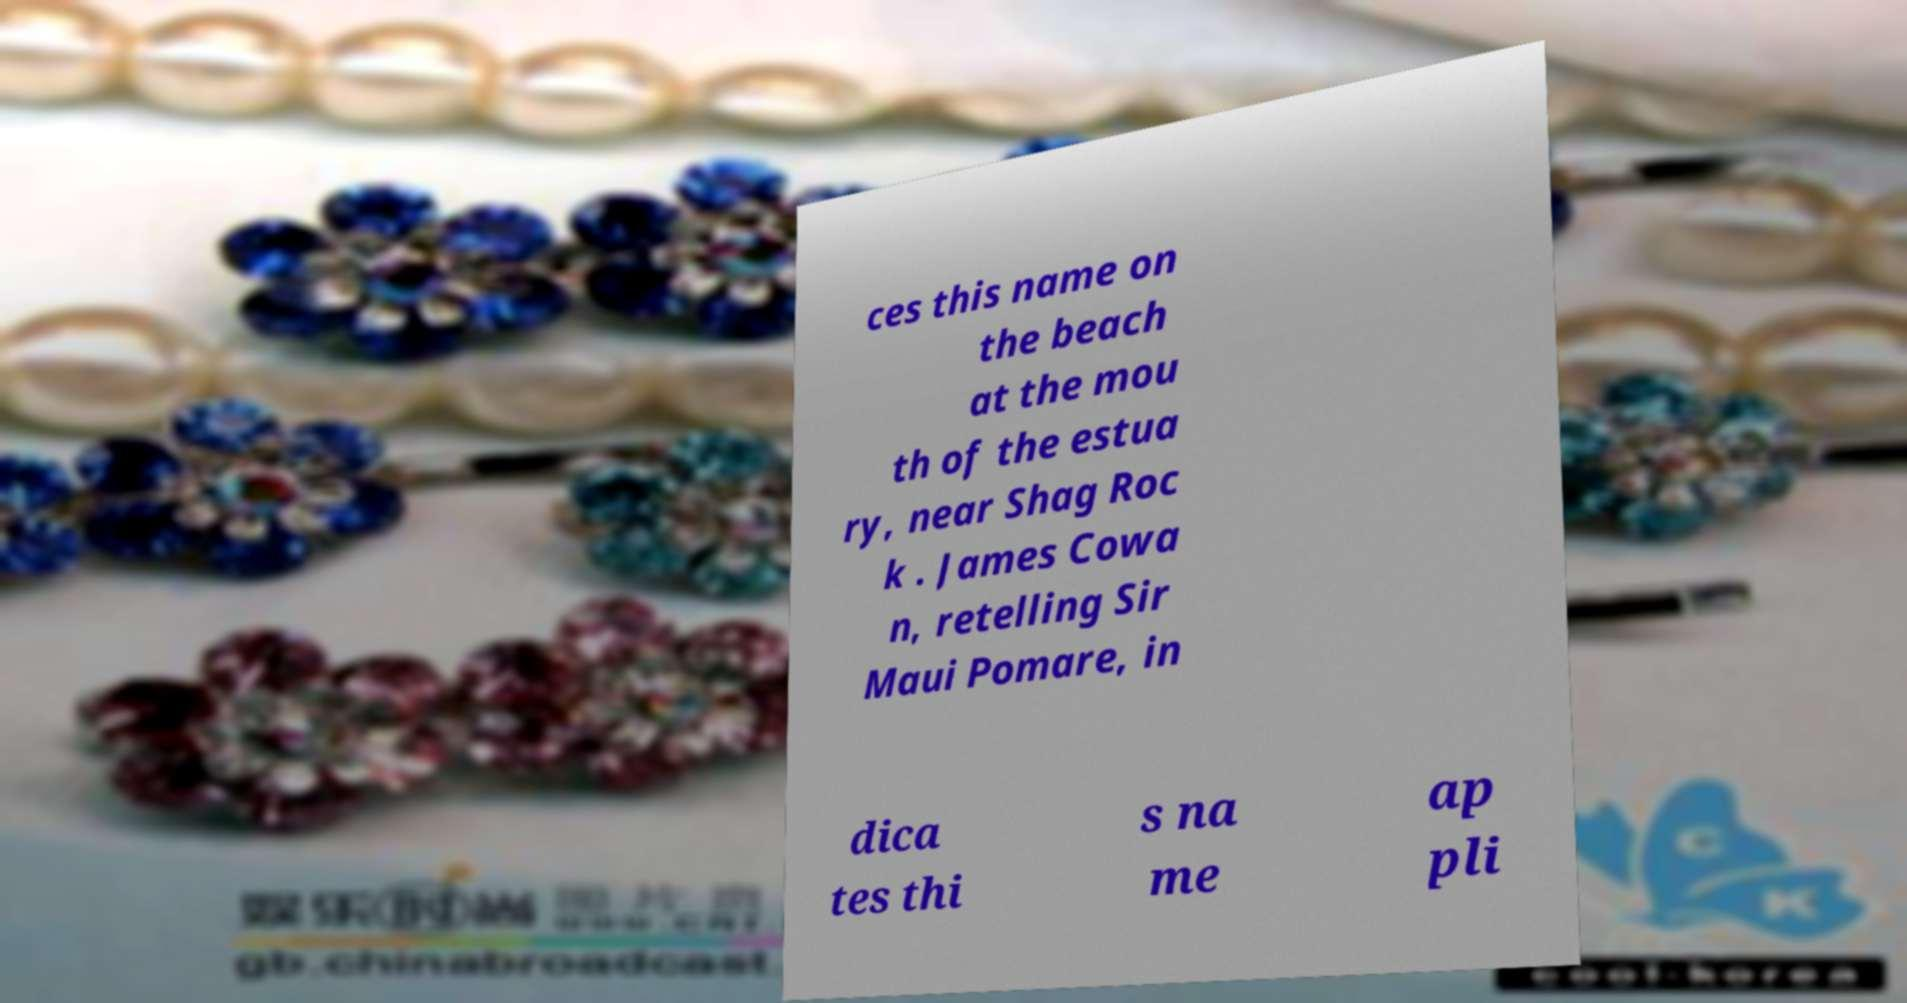What messages or text are displayed in this image? I need them in a readable, typed format. ces this name on the beach at the mou th of the estua ry, near Shag Roc k . James Cowa n, retelling Sir Maui Pomare, in dica tes thi s na me ap pli 